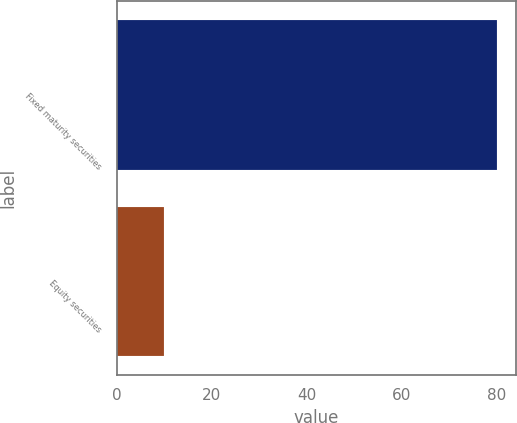Convert chart to OTSL. <chart><loc_0><loc_0><loc_500><loc_500><bar_chart><fcel>Fixed maturity securities<fcel>Equity securities<nl><fcel>80<fcel>10<nl></chart> 